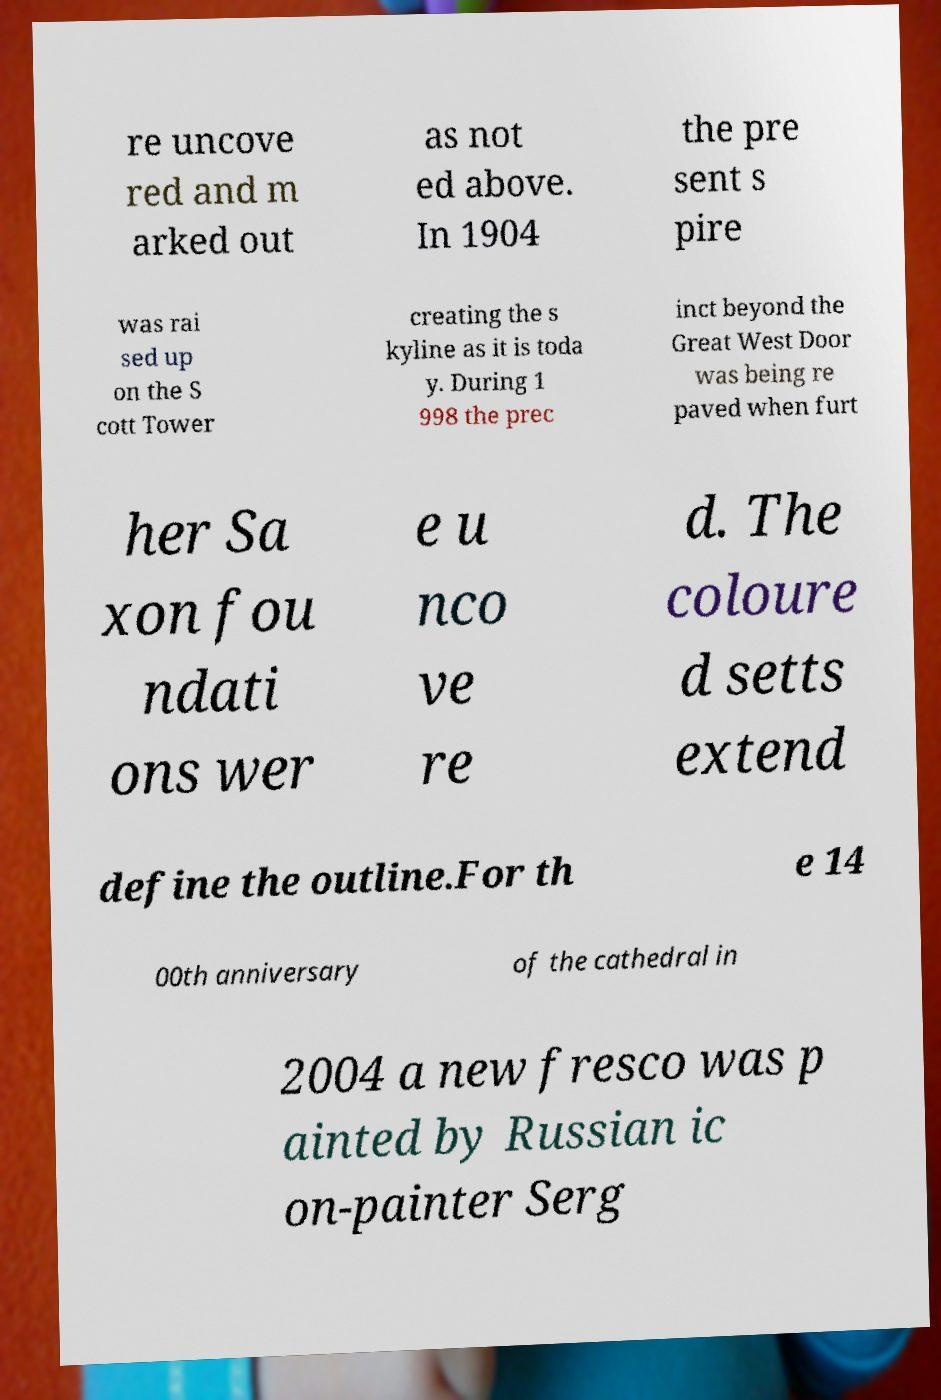Please identify and transcribe the text found in this image. re uncove red and m arked out as not ed above. In 1904 the pre sent s pire was rai sed up on the S cott Tower creating the s kyline as it is toda y. During 1 998 the prec inct beyond the Great West Door was being re paved when furt her Sa xon fou ndati ons wer e u nco ve re d. The coloure d setts extend define the outline.For th e 14 00th anniversary of the cathedral in 2004 a new fresco was p ainted by Russian ic on-painter Serg 